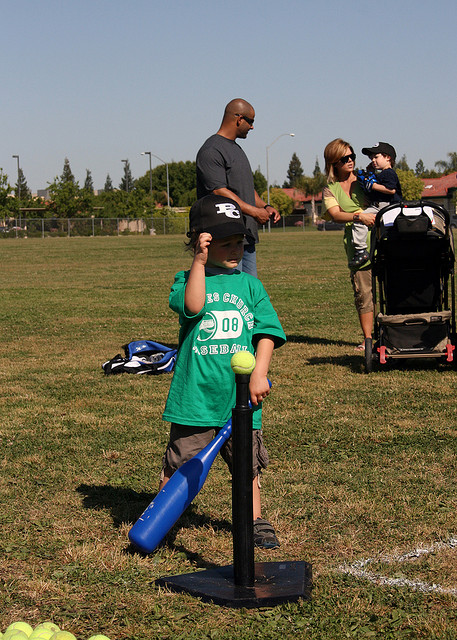Identify the text displayed in this image. 08 08 SEB 